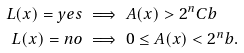Convert formula to latex. <formula><loc_0><loc_0><loc_500><loc_500>L ( x ) = y e s & \implies A ( x ) > 2 ^ { n } C b \\ L ( x ) = n o & \implies 0 \leq A ( x ) < 2 ^ { n } b .</formula> 